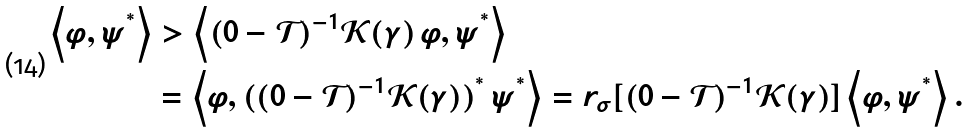<formula> <loc_0><loc_0><loc_500><loc_500>\left \langle \varphi , \psi ^ { ^ { * } } \right \rangle & > \left \langle ( 0 - \mathcal { T } ) ^ { - 1 } \mathcal { K } ( \gamma ) \, \varphi , \psi ^ { ^ { * } } \right \rangle \\ & = \left \langle \varphi , ( ( 0 - \mathcal { T } ) ^ { - 1 } \mathcal { K } ( \gamma ) ) ^ { ^ { * } } \, \psi ^ { ^ { * } } \right \rangle = r _ { \sigma } [ ( 0 - \mathcal { T } ) ^ { - 1 } \mathcal { K } ( \gamma ) ] \left \langle \varphi , \psi ^ { ^ { * } } \right \rangle .</formula> 